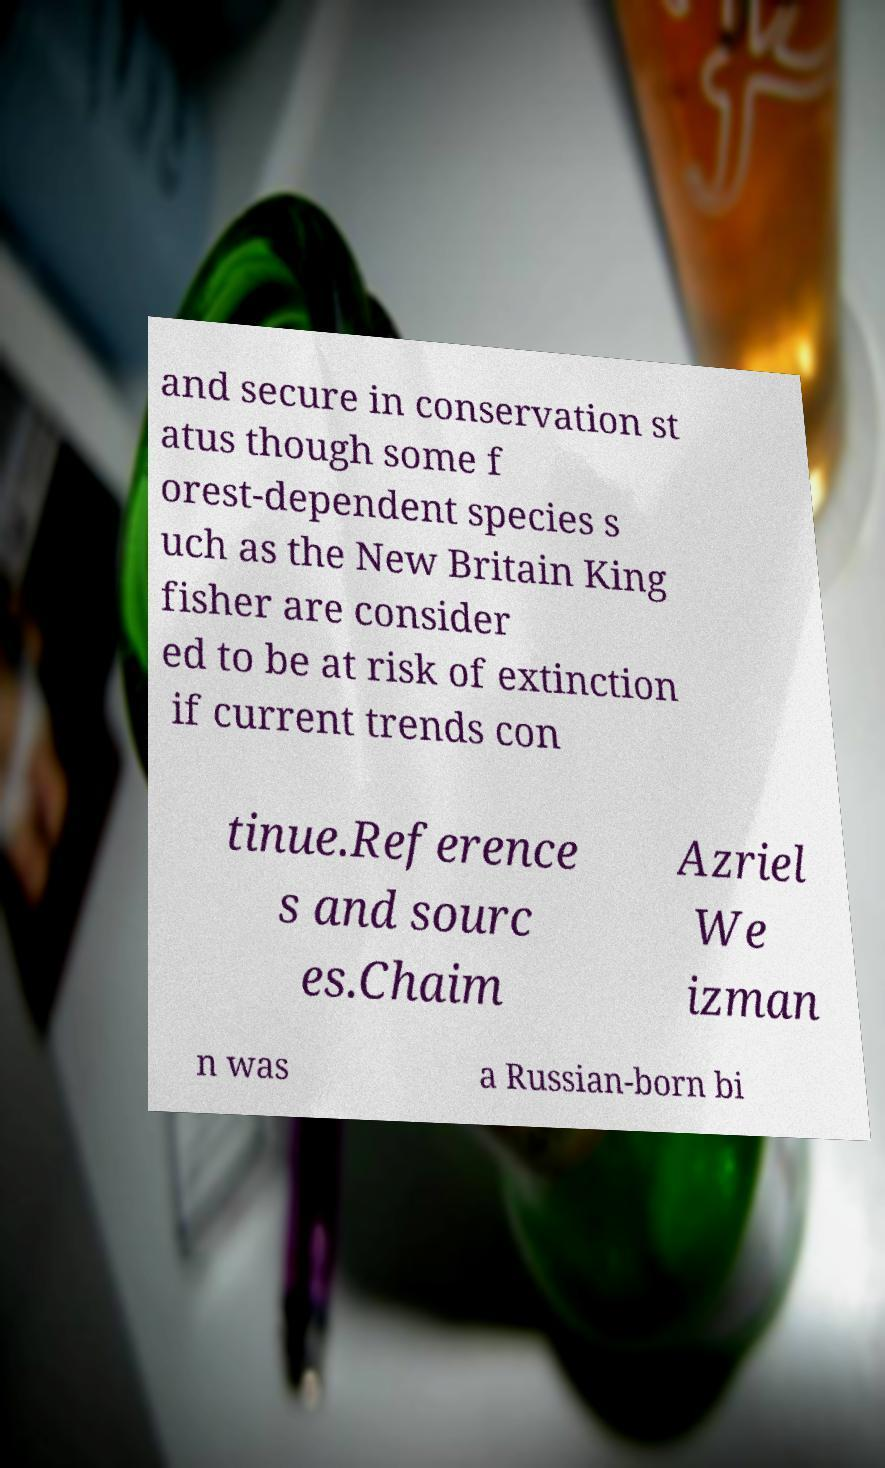Please identify and transcribe the text found in this image. and secure in conservation st atus though some f orest-dependent species s uch as the New Britain King fisher are consider ed to be at risk of extinction if current trends con tinue.Reference s and sourc es.Chaim Azriel We izman n was a Russian-born bi 